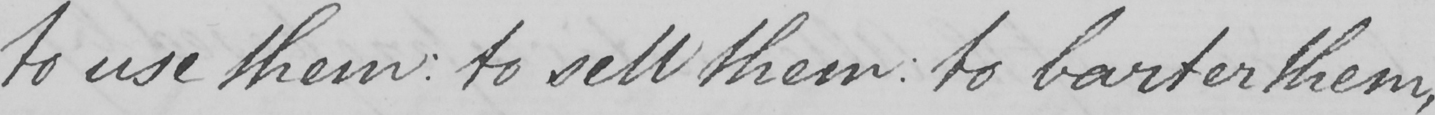Please transcribe the handwritten text in this image. to use them :  to sell them :  to barter them , 